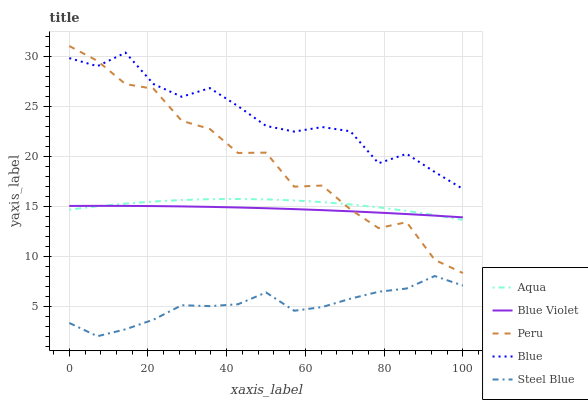Does Steel Blue have the minimum area under the curve?
Answer yes or no. Yes. Does Blue have the maximum area under the curve?
Answer yes or no. Yes. Does Aqua have the minimum area under the curve?
Answer yes or no. No. Does Aqua have the maximum area under the curve?
Answer yes or no. No. Is Blue Violet the smoothest?
Answer yes or no. Yes. Is Peru the roughest?
Answer yes or no. Yes. Is Aqua the smoothest?
Answer yes or no. No. Is Aqua the roughest?
Answer yes or no. No. Does Steel Blue have the lowest value?
Answer yes or no. Yes. Does Aqua have the lowest value?
Answer yes or no. No. Does Peru have the highest value?
Answer yes or no. Yes. Does Aqua have the highest value?
Answer yes or no. No. Is Steel Blue less than Aqua?
Answer yes or no. Yes. Is Aqua greater than Steel Blue?
Answer yes or no. Yes. Does Blue intersect Peru?
Answer yes or no. Yes. Is Blue less than Peru?
Answer yes or no. No. Is Blue greater than Peru?
Answer yes or no. No. Does Steel Blue intersect Aqua?
Answer yes or no. No. 